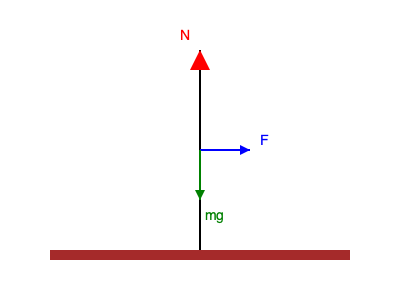In a balance beam routine, a gymnast performs a static hold where her center of mass is directly above her feet. Given that her mass is 50 kg and the acceleration due to gravity is 9.8 m/s², what is the magnitude of the normal force (N) exerted by the beam on the gymnast's feet? To solve this problem, we need to analyze the forces acting on the gymnast:

1. The force of gravity (weight): $F_g = mg$
   Where $m$ is the mass of the gymnast and $g$ is the acceleration due to gravity.

2. The normal force (N) exerted by the beam on the gymnast's feet.

In a static equilibrium situation, the sum of all forces must be zero. Since the gymnast's center of mass is directly above her feet, there are no horizontal forces to consider. We only need to balance the vertical forces.

Step 1: Calculate the force of gravity (weight)
$F_g = mg = 50 \text{ kg} \times 9.8 \text{ m/s²} = 490 \text{ N}$

Step 2: Apply the equilibrium condition
For vertical equilibrium: $\sum F_y = 0$
$N - F_g = 0$
$N - 490 \text{ N} = 0$
$N = 490 \text{ N}$

Therefore, the normal force exerted by the beam on the gymnast's feet is equal in magnitude but opposite in direction to the force of gravity.
Answer: 490 N 